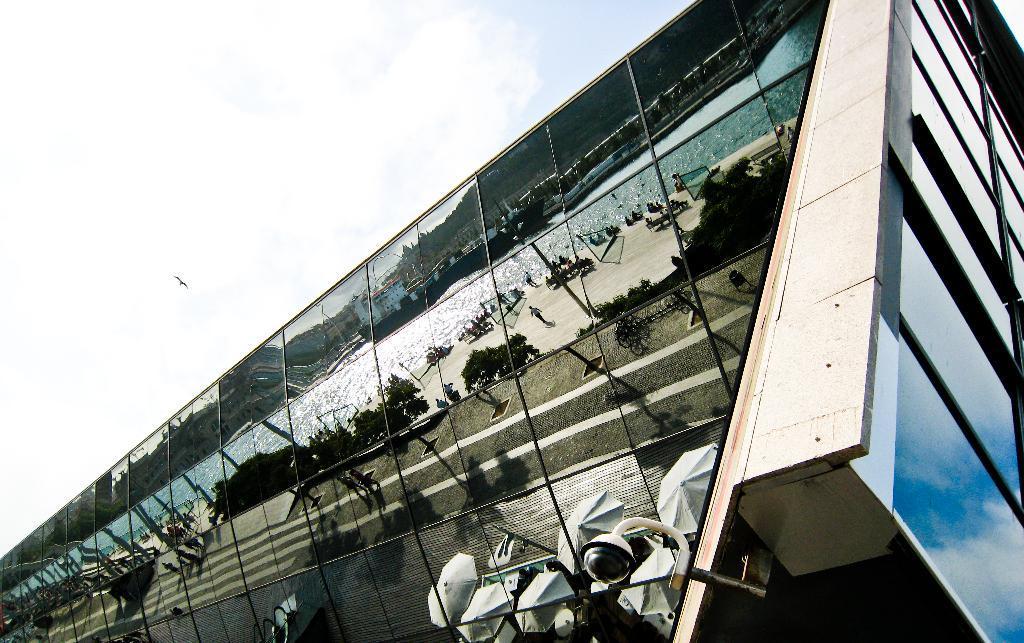Can you describe this image briefly? In this image we can see a building on which a security camera is attached and in the background we can see a bird is flying in the sky. 